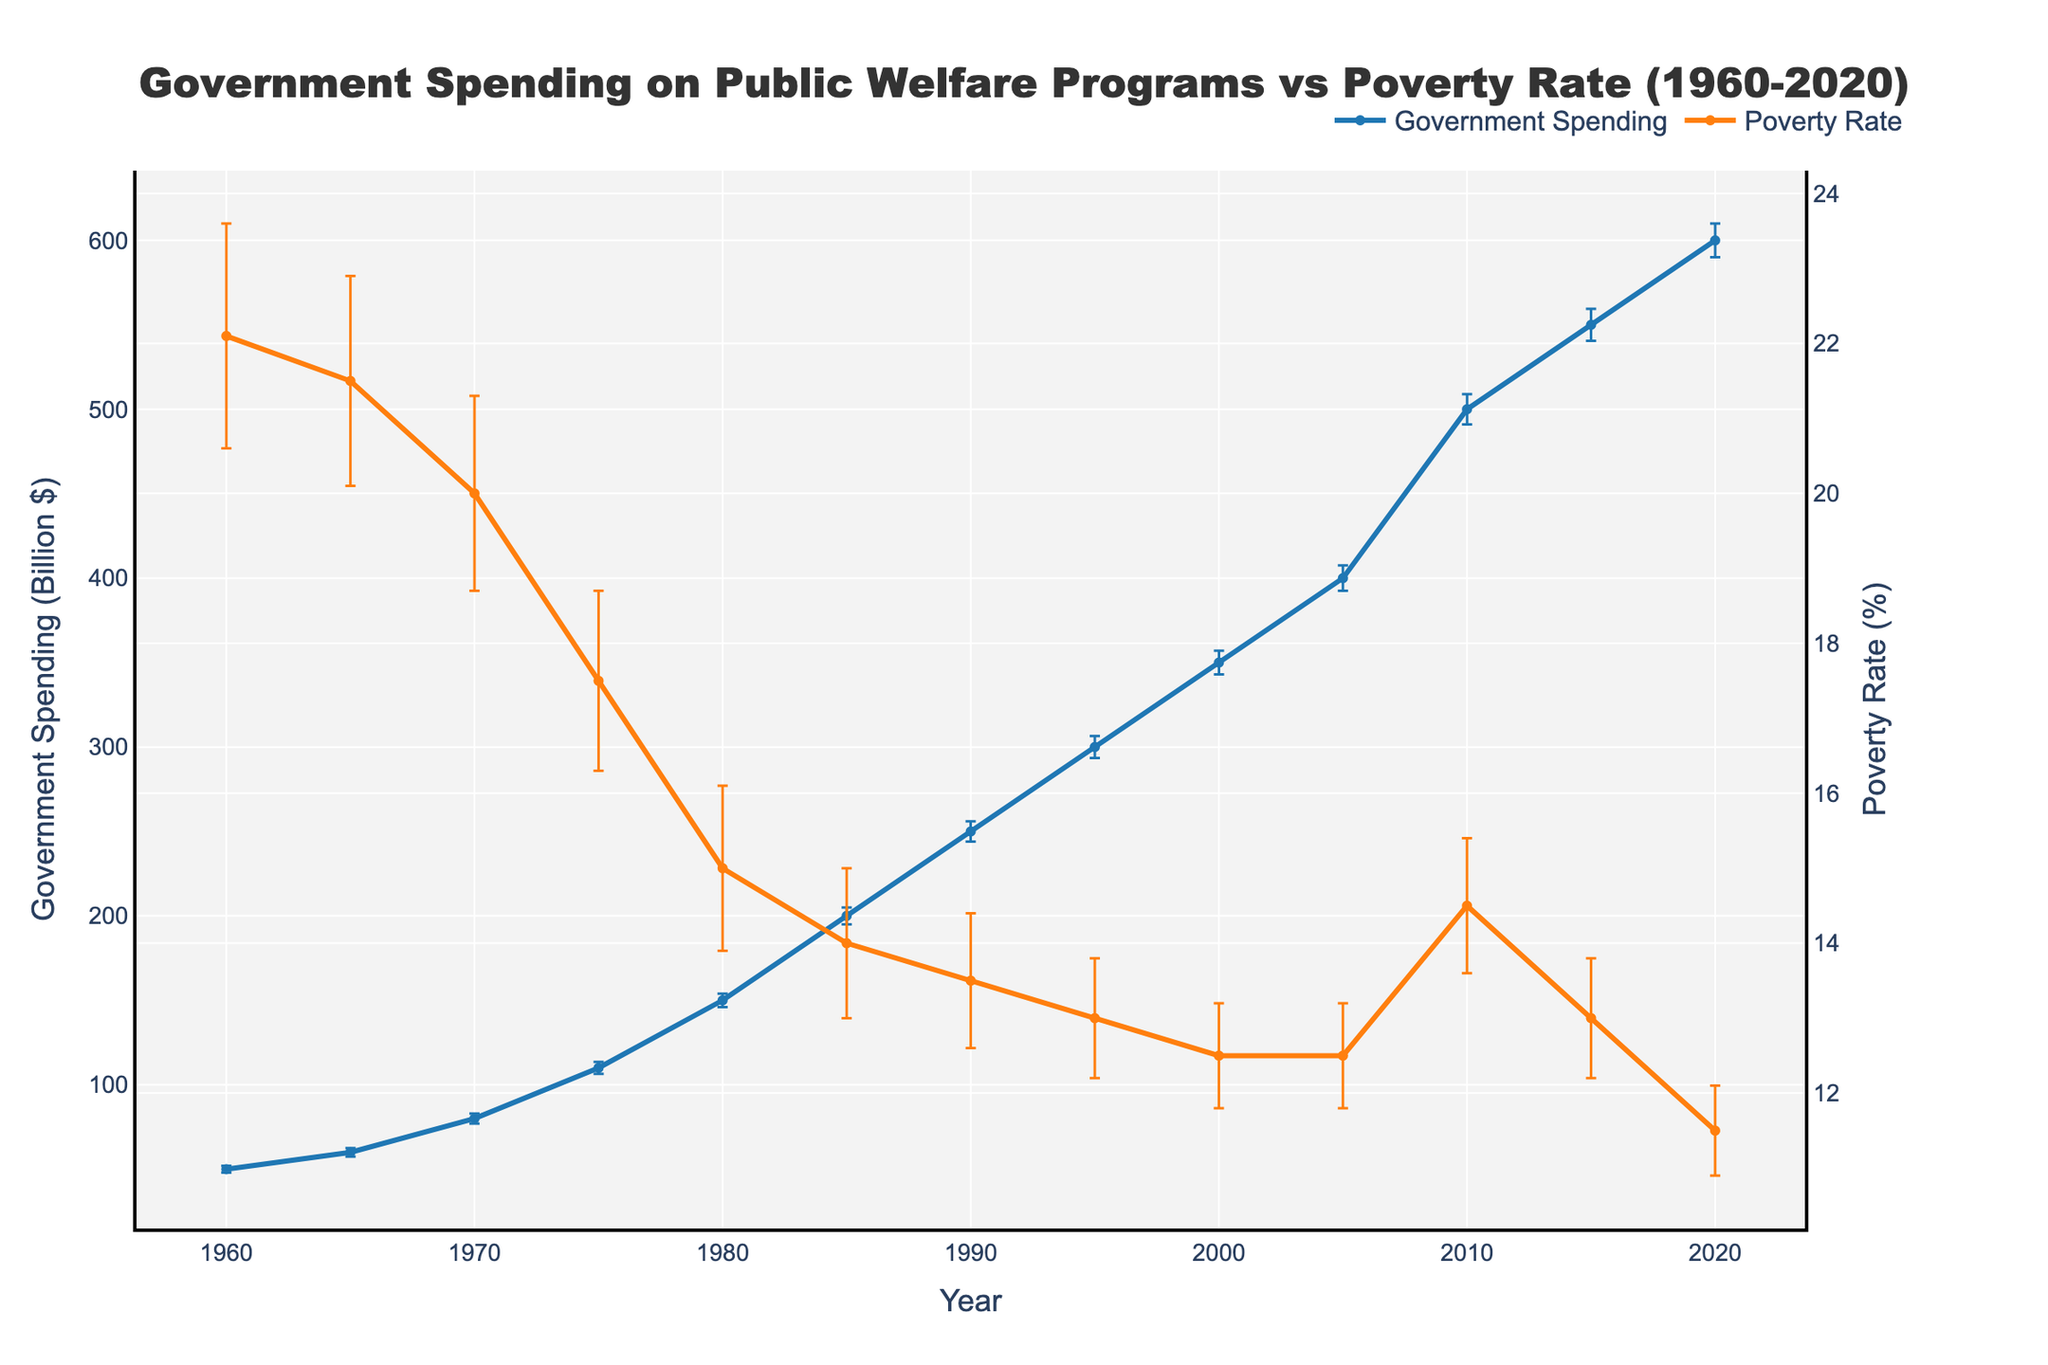What does the title of the figure indicate? The title of the figure is "Government Spending on Public Welfare Programs vs Poverty Rate (1960-2020)", indicating a comparison of two trends: government spending on public welfare programs and the poverty rate over the years from 1960 to 2020.
Answer: Comparison of government spending and poverty rate from 1960 to 2020 How does government spending on public welfare programs change from 1960 to 2020? To understand the change, we look at the line representing government spending, which shows an overall upward trend from 50 billion dollars in 1960 to 600 billion dollars in 2020.
Answer: It increases What are the error bars in the figure, and what do they represent? Error bars in the figure represent the standard errors for both government spending and poverty rate, indicating the range of uncertainty or variability in the data points.
Answer: They represent standard errors What year shows the highest government spending, and what is the amount? We examine the plot and see that the highest point in the government spending trace is in 2020, with an amount indicated at 600 billion dollars.
Answer: 2020, 600 billion dollars In which year is the poverty rate the highest, and what is the rate? Looking at the poverty rate line, the highest point is in 1960, where the rate is 22.1%.
Answer: 1960, 22.1% From 1960 to 2020, what is the average government spending on public welfare programs? We sum all government spending data points and divide by the number of years (13 points): 
(50 + 60 + 80 + 110 + 150 + 200 + 250 + 300 + 350 + 400 + 500 + 550 + 600) / 13 = 3600 / 13 = approximately 276.92 billion dollars.
Answer: 276.92 billion dollars Which year shows the most significant decline in the poverty rate from the previous year? To identify this, we need to calculate the year-on-year changes in the poverty rate and find the maximum decline. 1960-1965: (-0.6), 1965-1970: (-1.5), 1970-1975: (-2.5), 1975-1980: (-2.5), 1980-1985: (-1.0), 1985-1990: (-0.5), 1990-1995: (-0.5), 1995-2000: (-0.5), 2000-2005: (0.0), 2005-2010: (2.0), 2010-2015: (-1.5), 2015-2020: (-1.5). The largest decline occurs from 1975 to 1980.
Answer: 1975 to 1980 How do the error bars for poverty rate change over time? Observing the error bars for poverty rate, they generally decrease over time, indicating a reduction in variability or uncertainty.
Answer: Decrease over time Compare the change in government spending from 1970 to 1990 to the change in the poverty rate for the same period. From 1970 to 1990, government spending increased from 80 billion to 250 billion dollars, an increase of 170 billion dollars. The poverty rate decreased from 20.0% to 13.5%, a decrease of 6.5 percentage points.
Answer: Government spending increased by 170 billion dollars, and poverty rate decreased by 6.5 percentage points Is there any period where poverty rates show an increasing trend? Identify the period and the rate change. The poverty rate shows an increasing trend from 2005 to 2010, where it increased from 12.5% to 14.5%.
Answer: 2005 to 2010, increased by 2 percentage points 